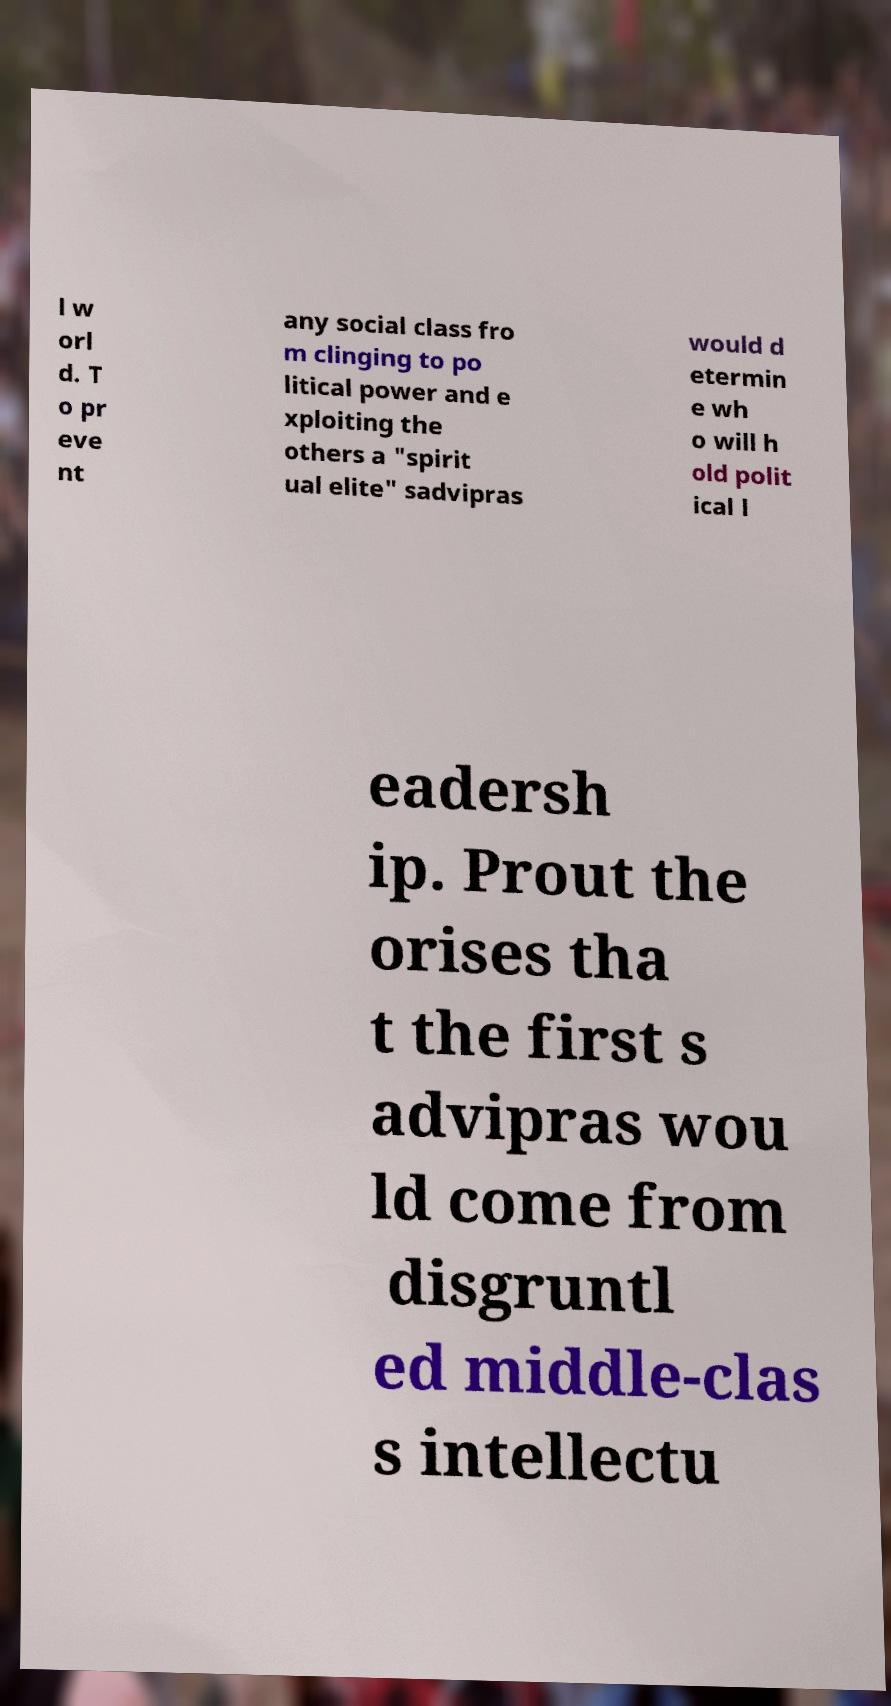Could you assist in decoding the text presented in this image and type it out clearly? l w orl d. T o pr eve nt any social class fro m clinging to po litical power and e xploiting the others a "spirit ual elite" sadvipras would d etermin e wh o will h old polit ical l eadersh ip. Prout the orises tha t the first s advipras wou ld come from disgruntl ed middle-clas s intellectu 